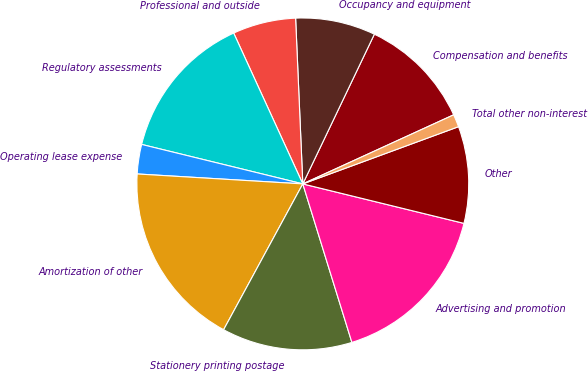Convert chart to OTSL. <chart><loc_0><loc_0><loc_500><loc_500><pie_chart><fcel>Compensation and benefits<fcel>Occupancy and equipment<fcel>Professional and outside<fcel>Regulatory assessments<fcel>Operating lease expense<fcel>Amortization of other<fcel>Stationery printing postage<fcel>Advertising and promotion<fcel>Other<fcel>Total other non-interest<nl><fcel>11.07%<fcel>7.79%<fcel>6.15%<fcel>14.34%<fcel>2.87%<fcel>18.04%<fcel>12.7%<fcel>16.4%<fcel>9.43%<fcel>1.23%<nl></chart> 